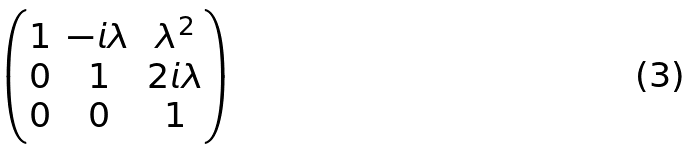Convert formula to latex. <formula><loc_0><loc_0><loc_500><loc_500>\begin{pmatrix} 1 & - i \lambda & \lambda ^ { 2 } \\ 0 & 1 & 2 i \lambda \\ 0 & 0 & 1 \end{pmatrix}</formula> 